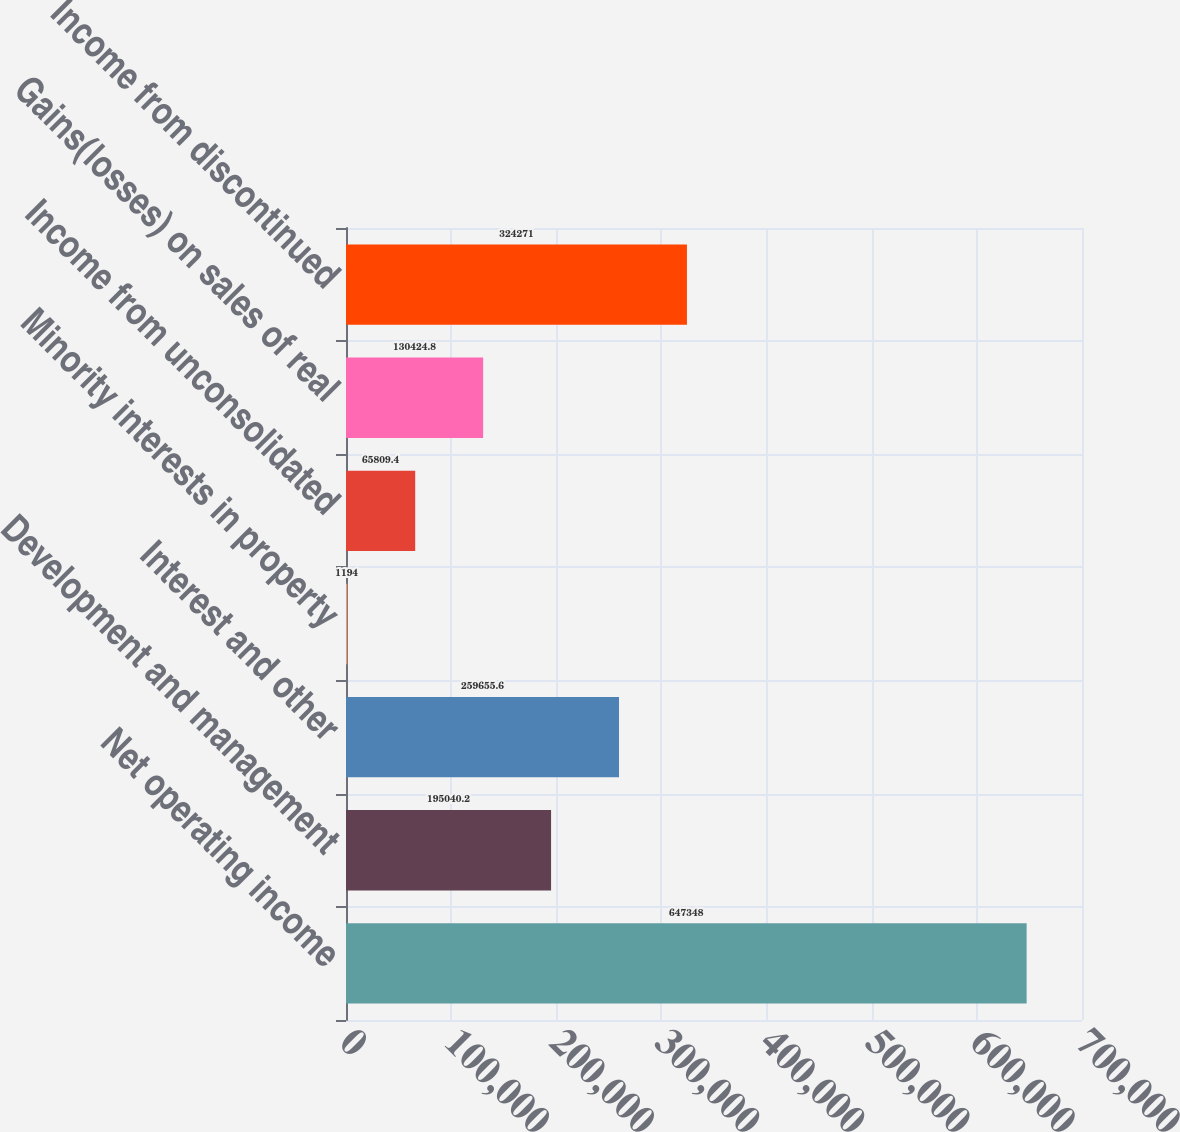Convert chart. <chart><loc_0><loc_0><loc_500><loc_500><bar_chart><fcel>Net operating income<fcel>Development and management<fcel>Interest and other<fcel>Minority interests in property<fcel>Income from unconsolidated<fcel>Gains(losses) on sales of real<fcel>Income from discontinued<nl><fcel>647348<fcel>195040<fcel>259656<fcel>1194<fcel>65809.4<fcel>130425<fcel>324271<nl></chart> 